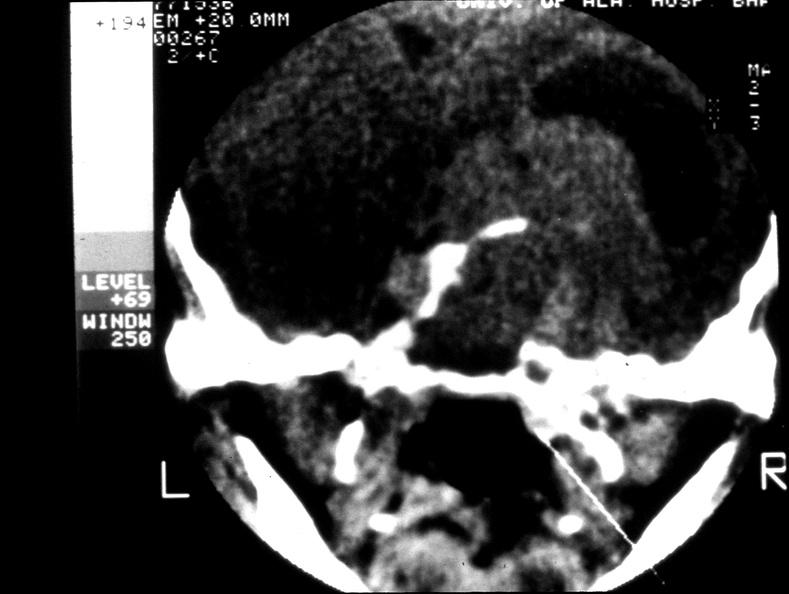where does this x-ray been taken?
Answer the question using a single word or phrase. Endocrine system 